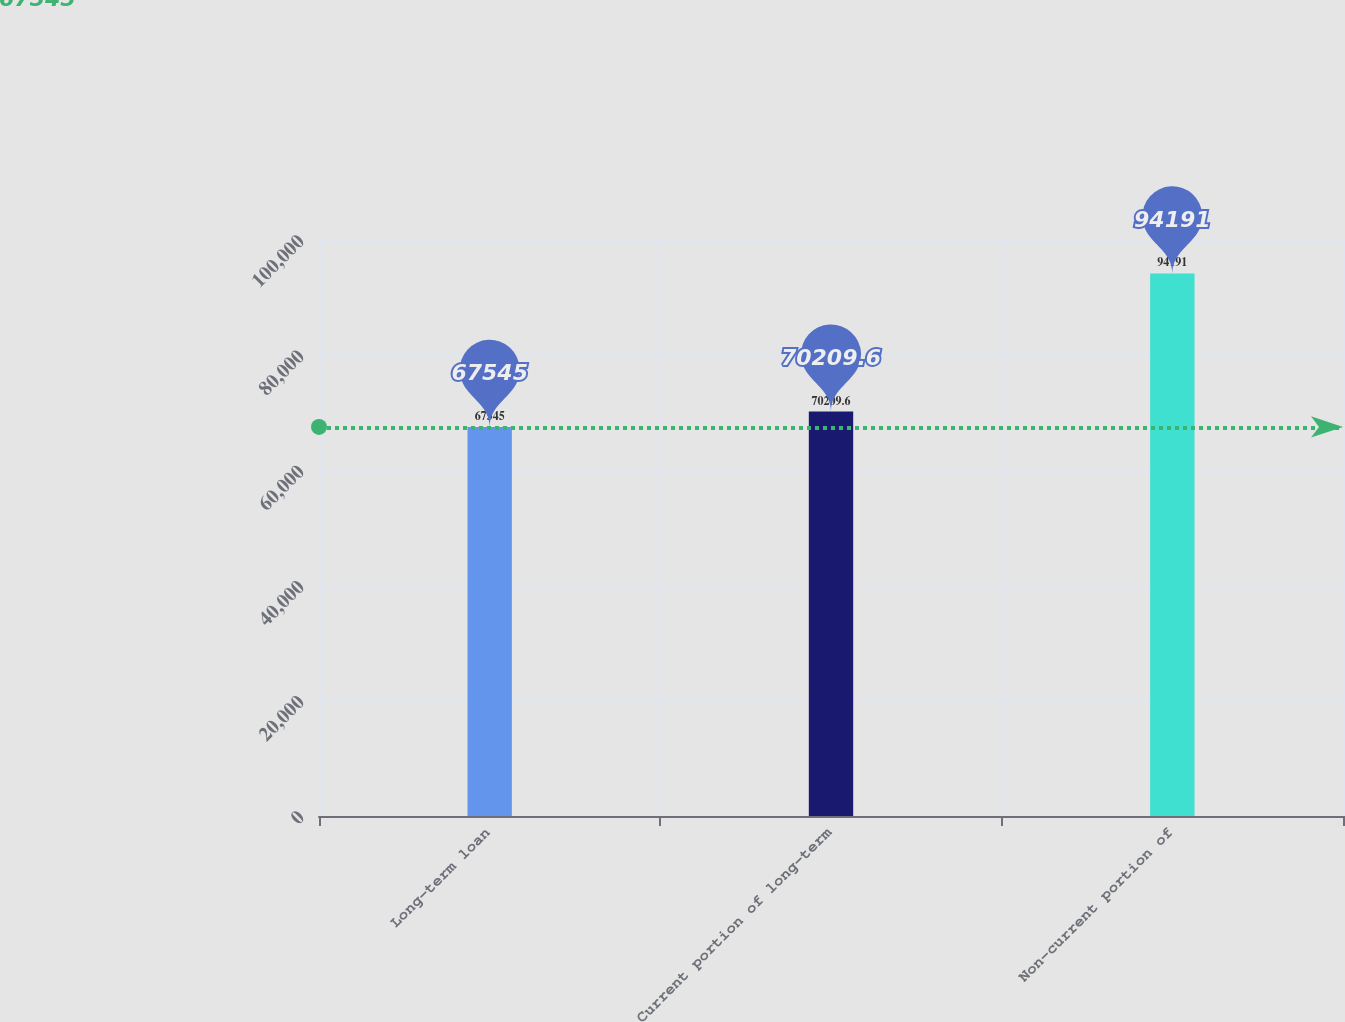Convert chart to OTSL. <chart><loc_0><loc_0><loc_500><loc_500><bar_chart><fcel>Long-term loan<fcel>Current portion of long-term<fcel>Non-current portion of<nl><fcel>67545<fcel>70209.6<fcel>94191<nl></chart> 